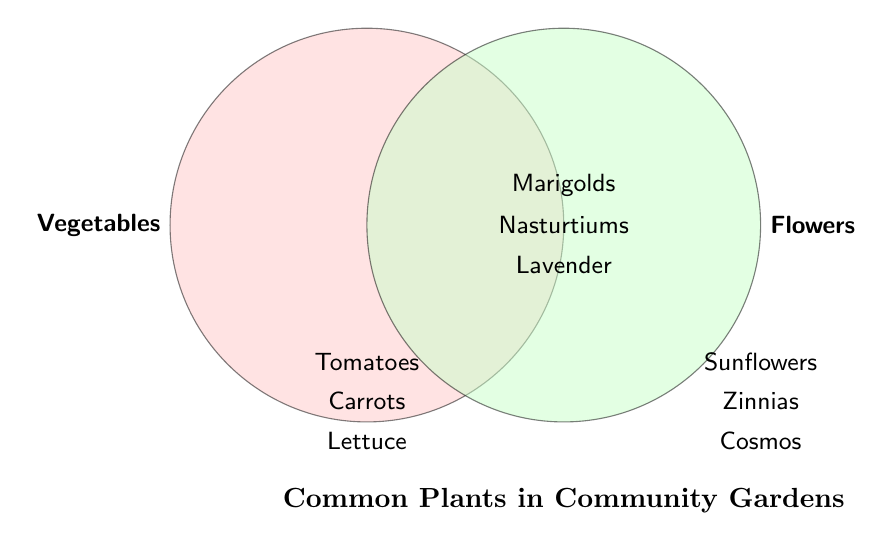What categories are shown on the Venn Diagram? The Venn Diagram displays two primary categories: Vegetables and Flowers.
Answer: Vegetables and Flowers Which plants are found only as vegetables in community gardens? The diagram lists plants unique to the Vegetables category. These are tomatoes, carrots, lettuce, peppers, and cucumbers.
Answer: Tomatoes, Carrots, Lettuce, Peppers, Cucumbers Which plants are both vegetables and flowers? Plants that appear in the overlapping section of the Venn Diagram belong to both categories.
Answer: Marigolds, Nasturtiums, Lavender How many plants are listed under only flowers? The diagram contains flowers that are in the Flowers section but not in the intersection with Vegetables. They are sunflowers, zinnias, cosmos, daisies, petunias, and calendula. Counting these, we get a total of 6 flowers.
Answer: 6 Which category has more unique plants, Vegetables or Flowers? By counting the unique plants listed in each category, Vegetables have 5 (Tomatoes, Carrots, Lettuce, Peppers, Cucumbers), and Flowers have 6 (Sunflowers, Zinnias, Cosmos, Daisies, Calendula, Petunias).
Answer: Flowers Are there any plants that are not classified under both vegetables and flowers? Yes, the plants listed in the Vegetables or Flowers sections but not in the intersection are not classified under both. This includes tomatoes, carrots, lettuce, peppers, cucumbers (Vegetables) and sunflowers, zinnias, cosmos, daisies, calendula, petunias (Flowers).
Answer: Yes How many total plants are represented in the Venn Diagram? By counting the unique plants in the Venn Diagram, including both individual and common plants, we have: 5 Vegetables, 6 Flowers, and 3 shared. Total plants would be 5 + 6 + 3 = 14, but the 3 common plants shouldn't be double-counted, so 5 + 3 unique plants from Flowers making it 11 unique plants.
Answer: 11 